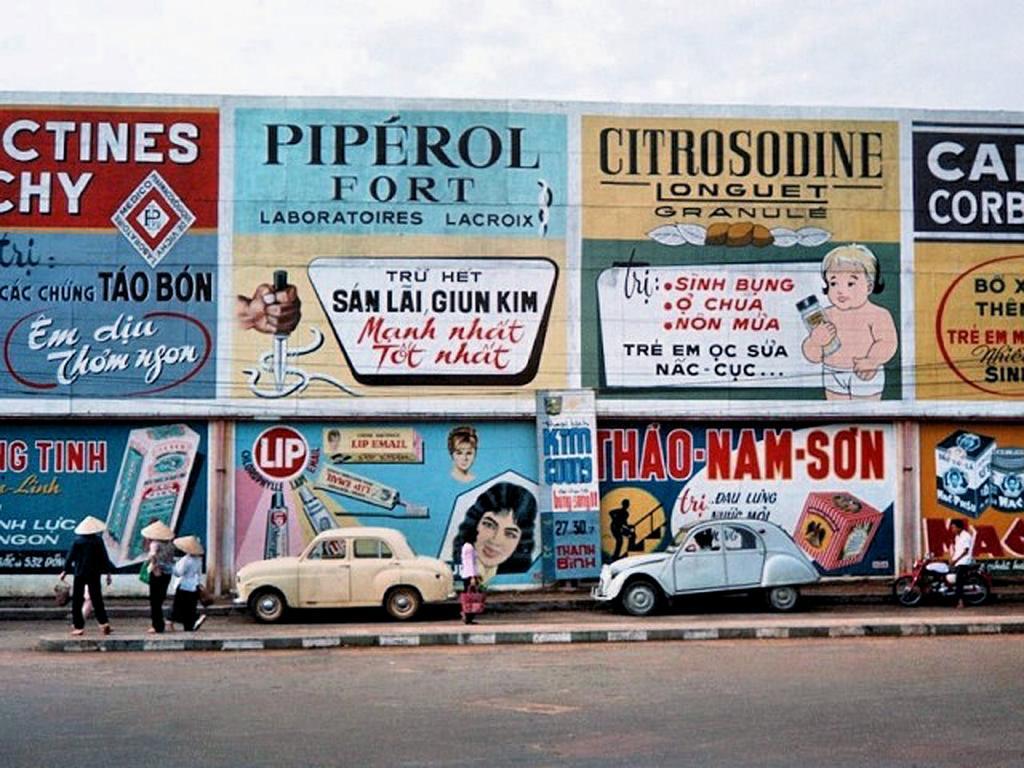Describe this image in one or two sentences. In this image I can see the road, the side walk, two cars which are cream and blue in color on the sidewalk, few persons standing on the sidewalk and a person on the motorbike. In the background I can see a huge wall with few paintings on it and the sky. 